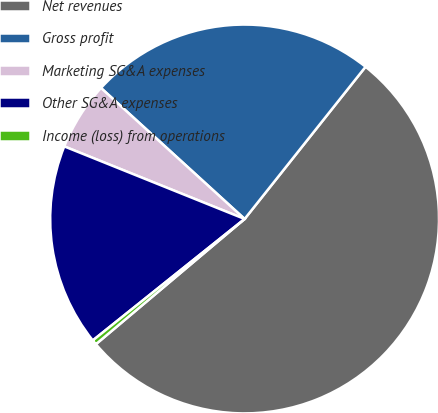Convert chart to OTSL. <chart><loc_0><loc_0><loc_500><loc_500><pie_chart><fcel>Net revenues<fcel>Gross profit<fcel>Marketing SG&A expenses<fcel>Other SG&A expenses<fcel>Income (loss) from operations<nl><fcel>53.18%<fcel>23.92%<fcel>5.68%<fcel>16.83%<fcel>0.4%<nl></chart> 